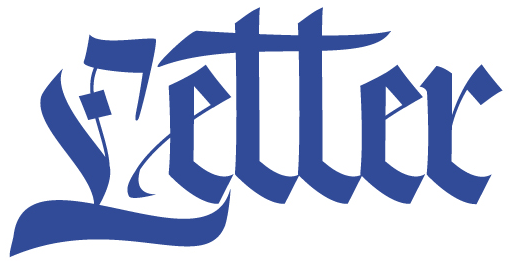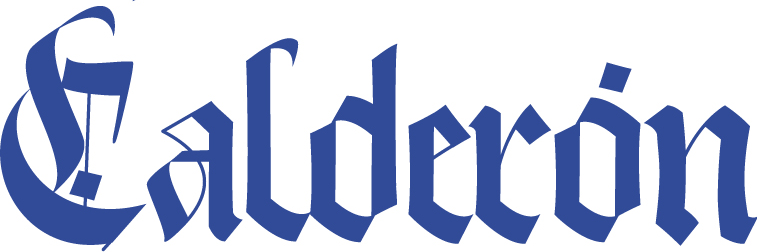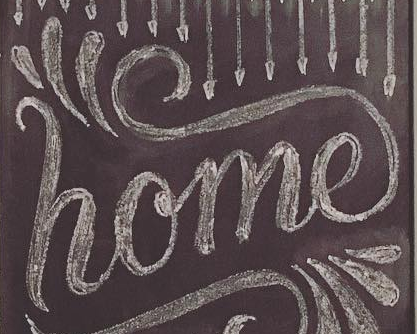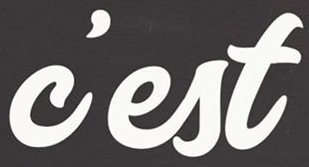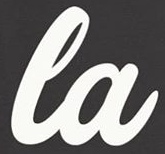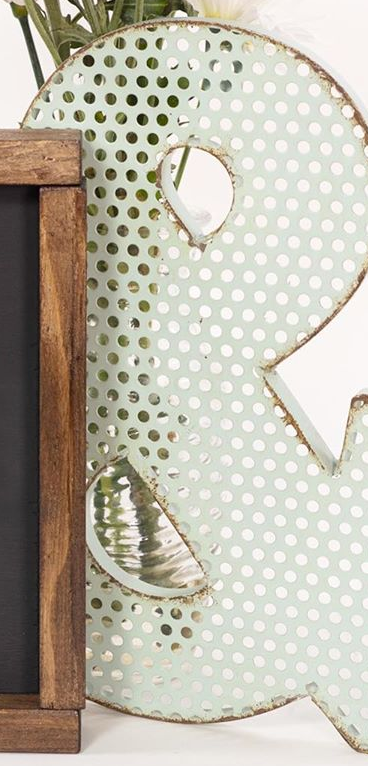Identify the words shown in these images in order, separated by a semicolon. Letter; Calderón; home; c'est; la; & 